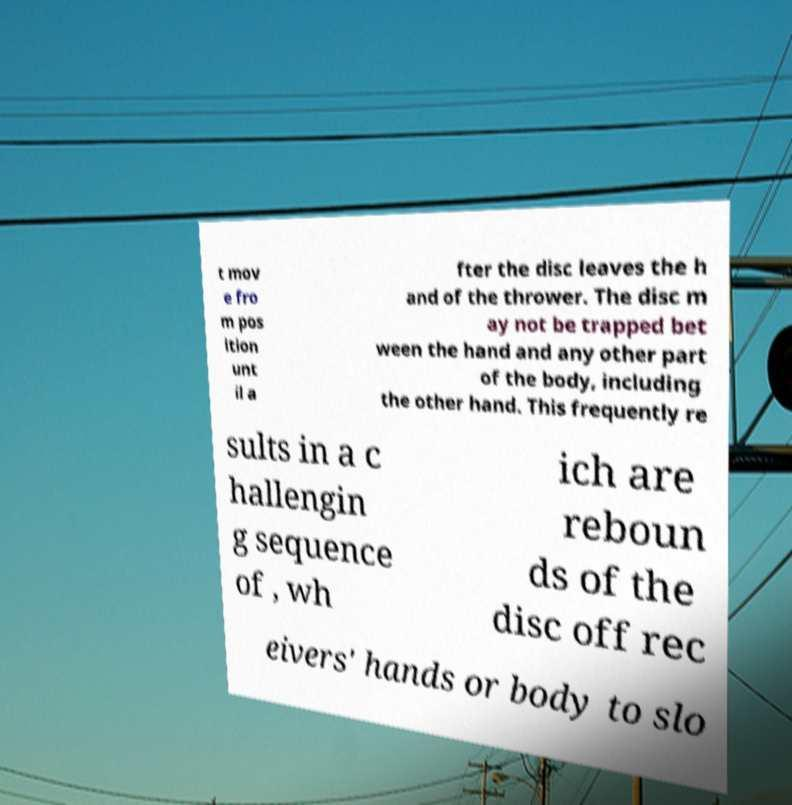What messages or text are displayed in this image? I need them in a readable, typed format. t mov e fro m pos ition unt il a fter the disc leaves the h and of the thrower. The disc m ay not be trapped bet ween the hand and any other part of the body, including the other hand. This frequently re sults in a c hallengin g sequence of , wh ich are reboun ds of the disc off rec eivers' hands or body to slo 